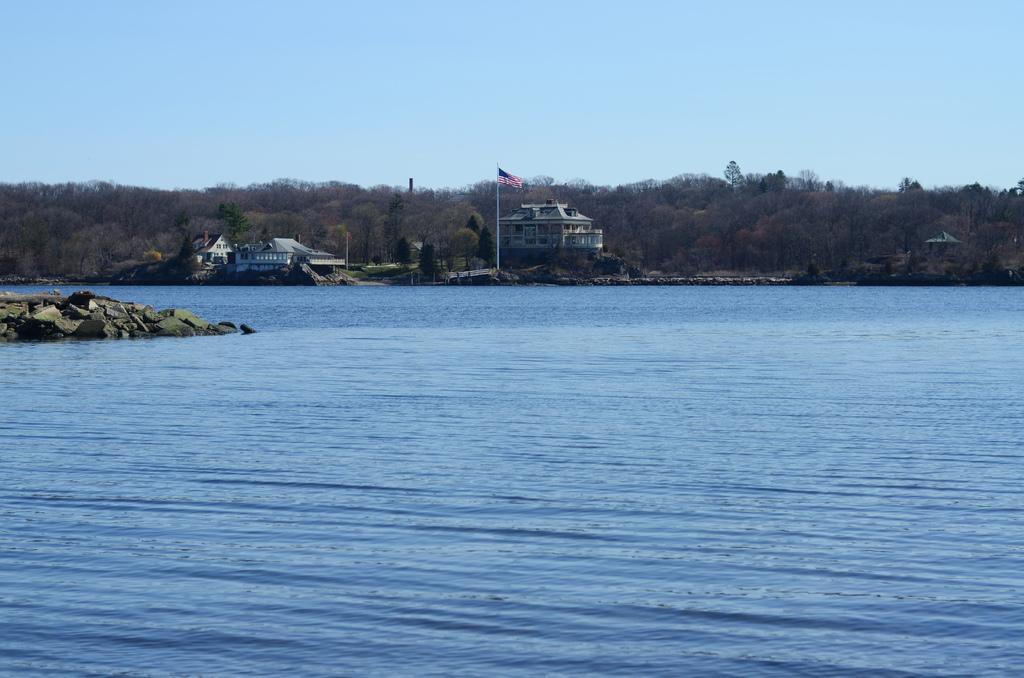Please provide a concise description of this image. In this picture we can see water and few rocks, in the background we can find few trees, buildings and a flag. 